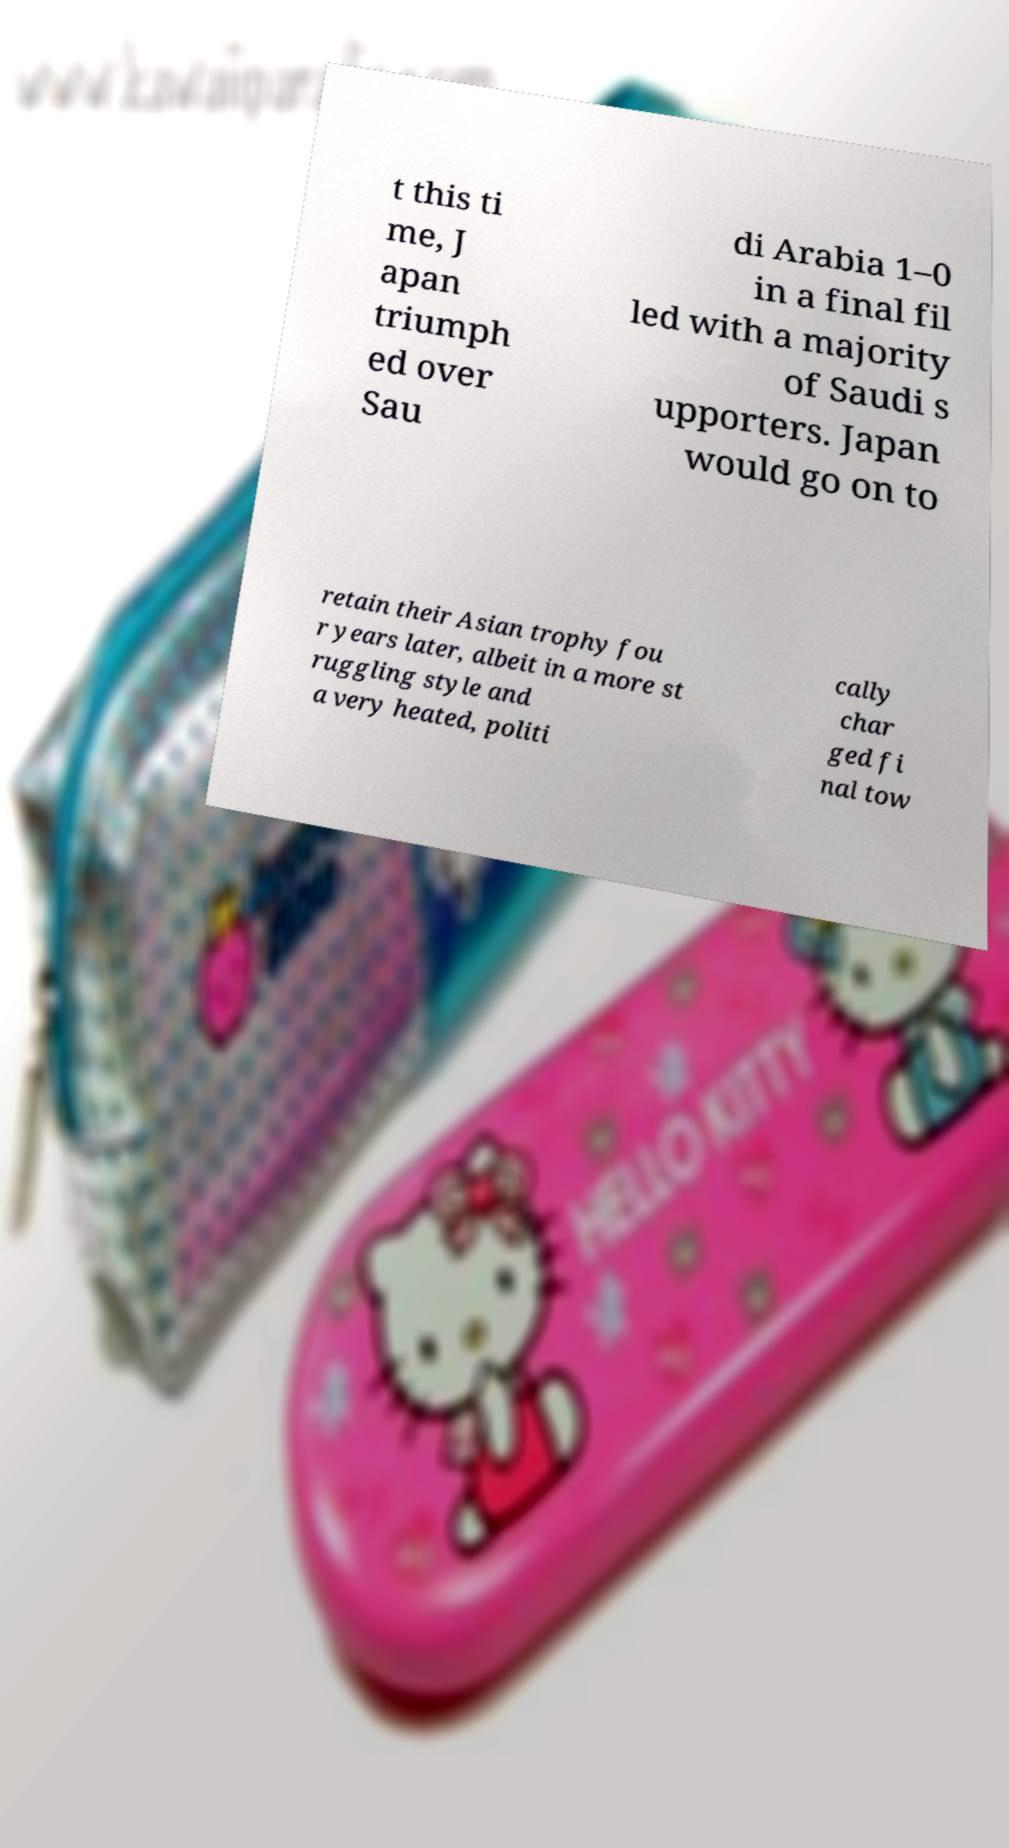Could you extract and type out the text from this image? t this ti me, J apan triumph ed over Sau di Arabia 1–0 in a final fil led with a majority of Saudi s upporters. Japan would go on to retain their Asian trophy fou r years later, albeit in a more st ruggling style and a very heated, politi cally char ged fi nal tow 